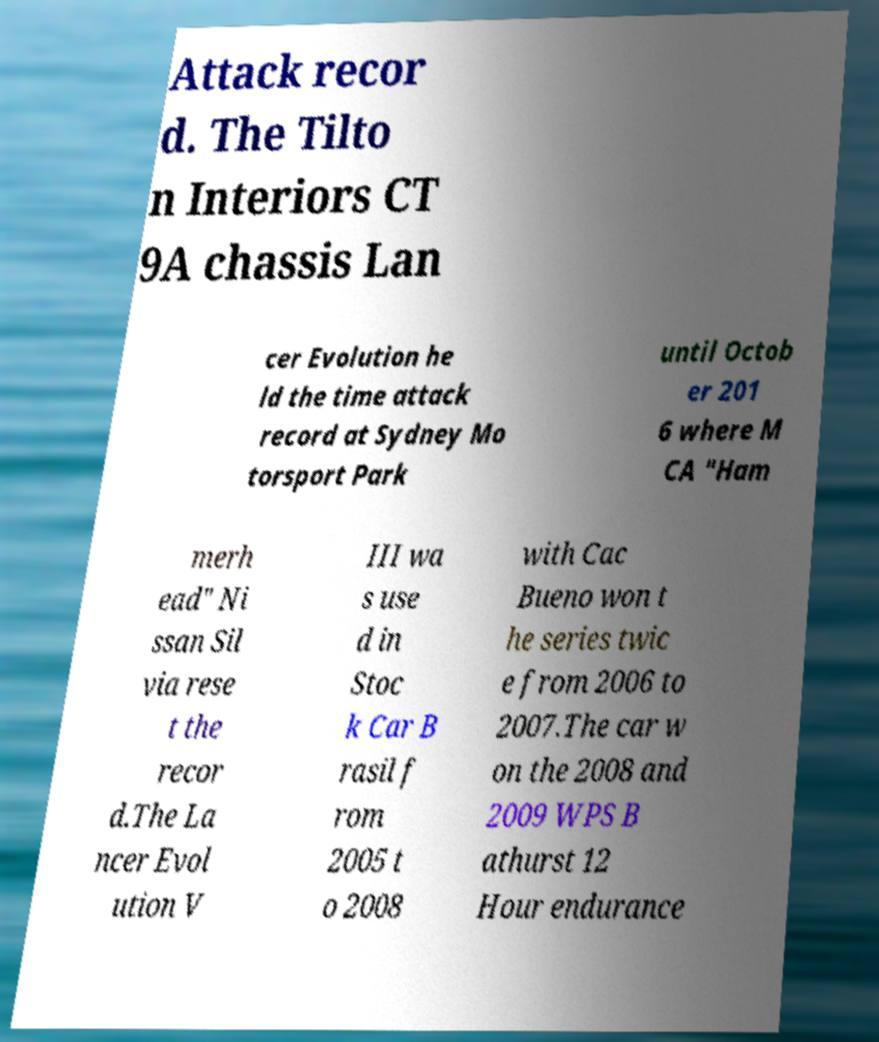There's text embedded in this image that I need extracted. Can you transcribe it verbatim? Attack recor d. The Tilto n Interiors CT 9A chassis Lan cer Evolution he ld the time attack record at Sydney Mo torsport Park until Octob er 201 6 where M CA "Ham merh ead" Ni ssan Sil via rese t the recor d.The La ncer Evol ution V III wa s use d in Stoc k Car B rasil f rom 2005 t o 2008 with Cac Bueno won t he series twic e from 2006 to 2007.The car w on the 2008 and 2009 WPS B athurst 12 Hour endurance 